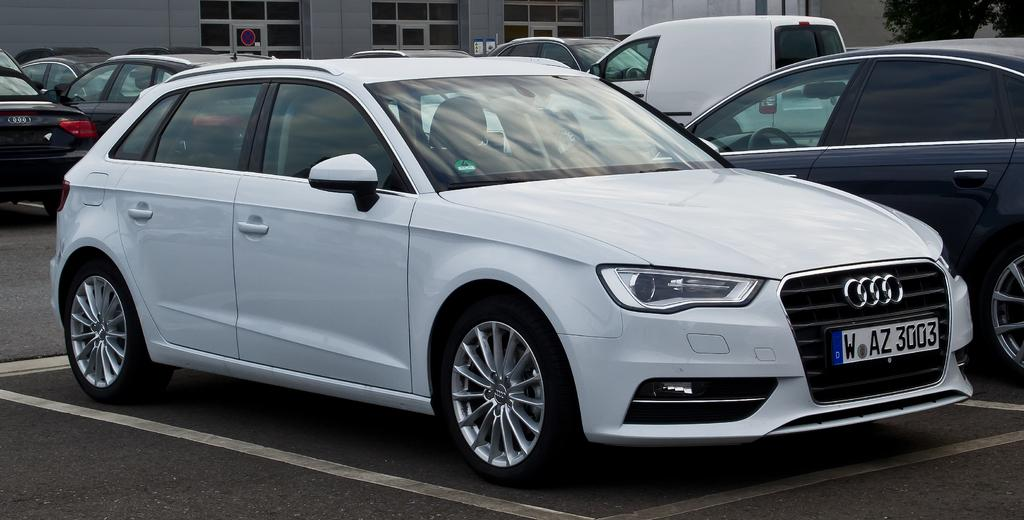What type of vehicles are in the front of the image? There are cars in the front of the image. What structures can be seen in the background of the image? There are buildings in the background of the image. Can you describe the vegetation in the background of the image? There is a tree on the right side of the background in the image. How many apples are hanging from the tree in the image? There are no apples present in the image; it only features a tree in the background. What type of coil is used to power the cars in the image? There is no coil present in the image, and the cars' power source is not mentioned. 